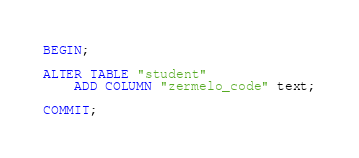<code> <loc_0><loc_0><loc_500><loc_500><_SQL_>BEGIN;

ALTER TABLE "student"
    ADD COLUMN "zermelo_code" text;

COMMIT;
</code> 